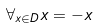Convert formula to latex. <formula><loc_0><loc_0><loc_500><loc_500>\forall _ { x \in D } x = - x</formula> 